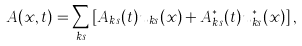<formula> <loc_0><loc_0><loc_500><loc_500>A ( x , t ) = \sum _ { k s } \left [ A _ { k s } ( t ) u _ { k s } ( x ) + A _ { k s } ^ { * } ( t ) u _ { k s } ^ { * } ( x ) \right ] ,</formula> 